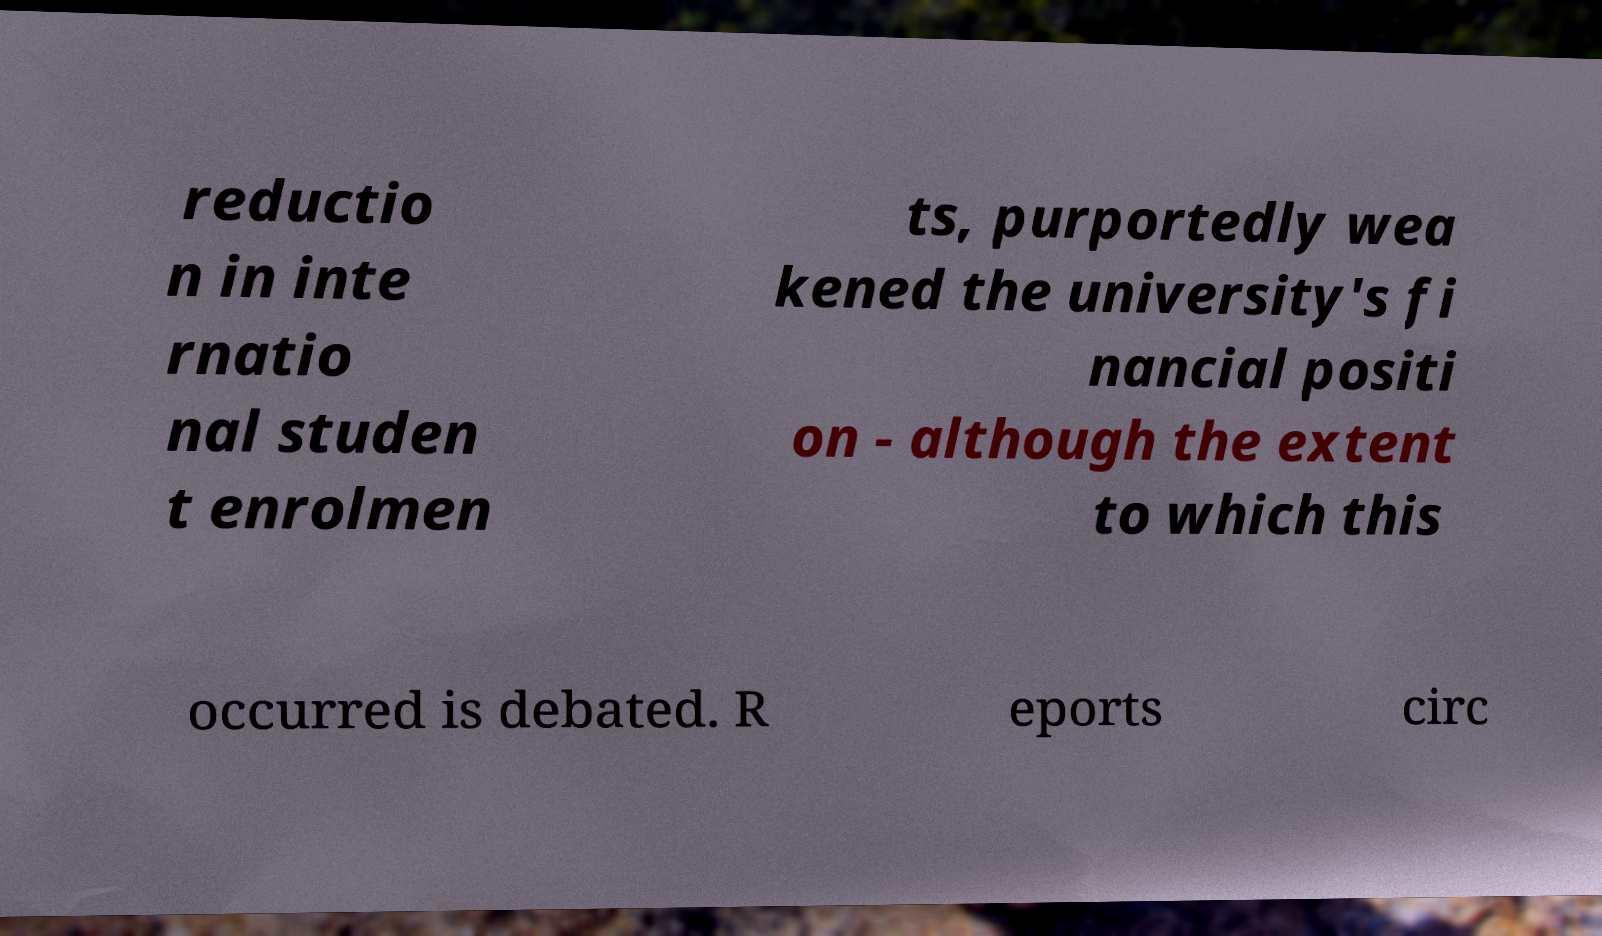Please identify and transcribe the text found in this image. reductio n in inte rnatio nal studen t enrolmen ts, purportedly wea kened the university's fi nancial positi on - although the extent to which this occurred is debated. R eports circ 